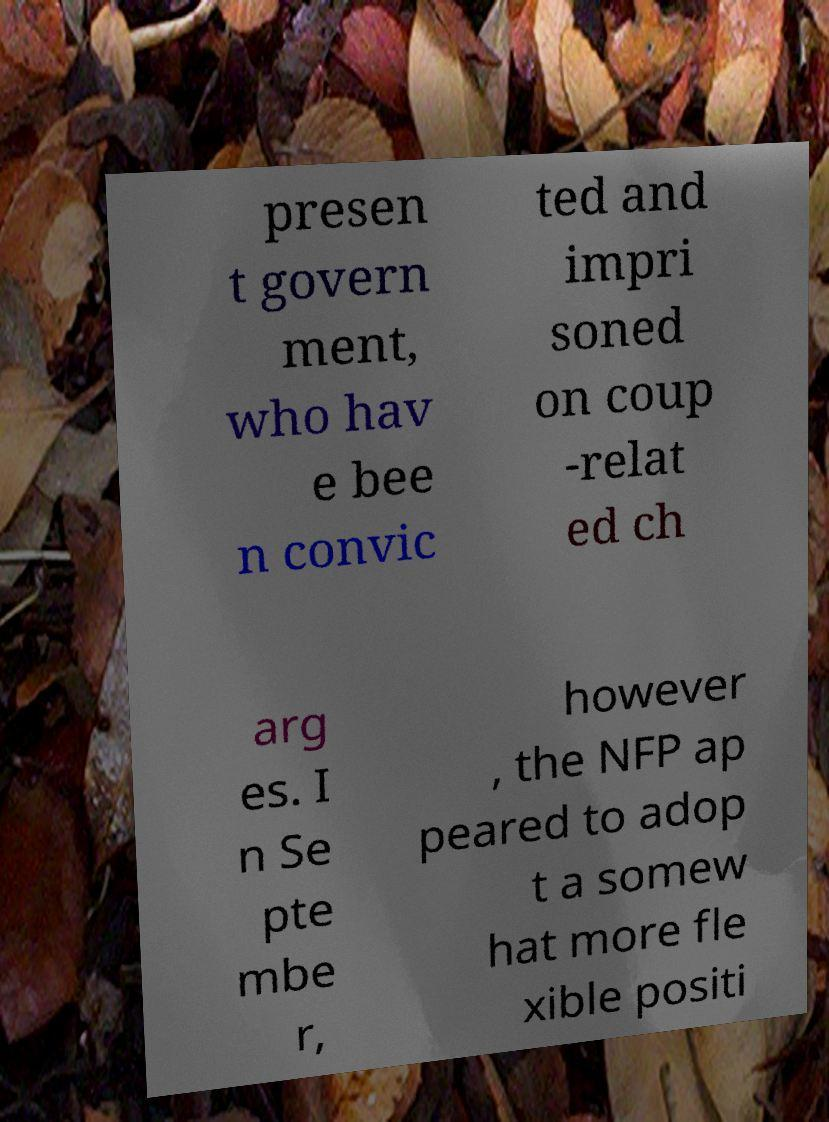Could you assist in decoding the text presented in this image and type it out clearly? presen t govern ment, who hav e bee n convic ted and impri soned on coup -relat ed ch arg es. I n Se pte mbe r, however , the NFP ap peared to adop t a somew hat more fle xible positi 